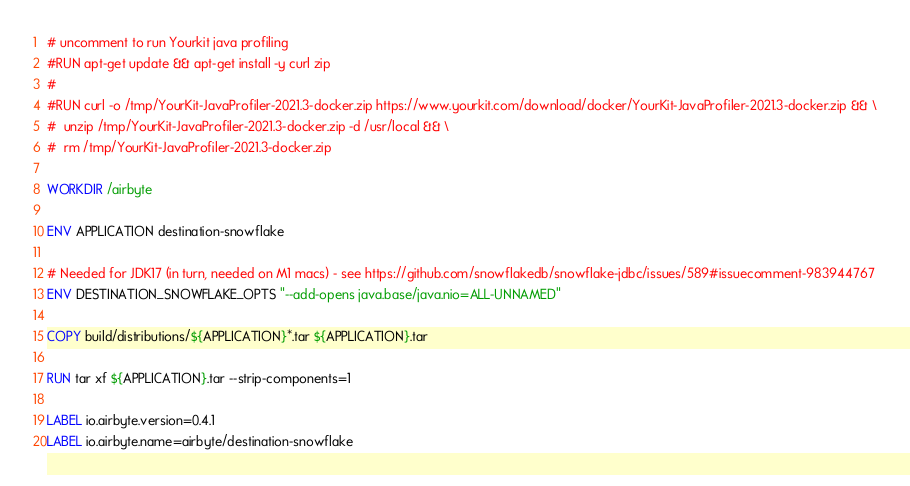Convert code to text. <code><loc_0><loc_0><loc_500><loc_500><_Dockerfile_>
# uncomment to run Yourkit java profiling
#RUN apt-get update && apt-get install -y curl zip
#
#RUN curl -o /tmp/YourKit-JavaProfiler-2021.3-docker.zip https://www.yourkit.com/download/docker/YourKit-JavaProfiler-2021.3-docker.zip && \
#  unzip /tmp/YourKit-JavaProfiler-2021.3-docker.zip -d /usr/local && \
#  rm /tmp/YourKit-JavaProfiler-2021.3-docker.zip

WORKDIR /airbyte

ENV APPLICATION destination-snowflake

# Needed for JDK17 (in turn, needed on M1 macs) - see https://github.com/snowflakedb/snowflake-jdbc/issues/589#issuecomment-983944767
ENV DESTINATION_SNOWFLAKE_OPTS "--add-opens java.base/java.nio=ALL-UNNAMED"

COPY build/distributions/${APPLICATION}*.tar ${APPLICATION}.tar

RUN tar xf ${APPLICATION}.tar --strip-components=1

LABEL io.airbyte.version=0.4.1
LABEL io.airbyte.name=airbyte/destination-snowflake
</code> 